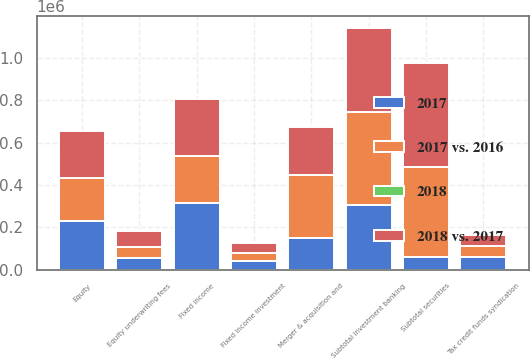Convert chart. <chart><loc_0><loc_0><loc_500><loc_500><stacked_bar_chart><ecel><fcel>Equity<fcel>Fixed income<fcel>Subtotal securities<fcel>Equity underwriting fees<fcel>Merger & acquisition and<fcel>Fixed income investment<fcel>Tax credit funds syndication<fcel>Subtotal investment banking<nl><fcel>2017 vs. 2016<fcel>202809<fcel>221684<fcel>424493<fcel>53262<fcel>296606<fcel>39430<fcel>51464<fcel>440762<nl><fcel>2018 vs. 2017<fcel>222942<fcel>267749<fcel>490691<fcel>72845<fcel>228422<fcel>43234<fcel>54098<fcel>398599<nl><fcel>2017<fcel>228346<fcel>316144<fcel>59424<fcel>54492<fcel>148503<fcel>41024<fcel>59424<fcel>303443<nl><fcel>2018<fcel>9<fcel>17<fcel>13<fcel>27<fcel>30<fcel>9<fcel>5<fcel>11<nl></chart> 